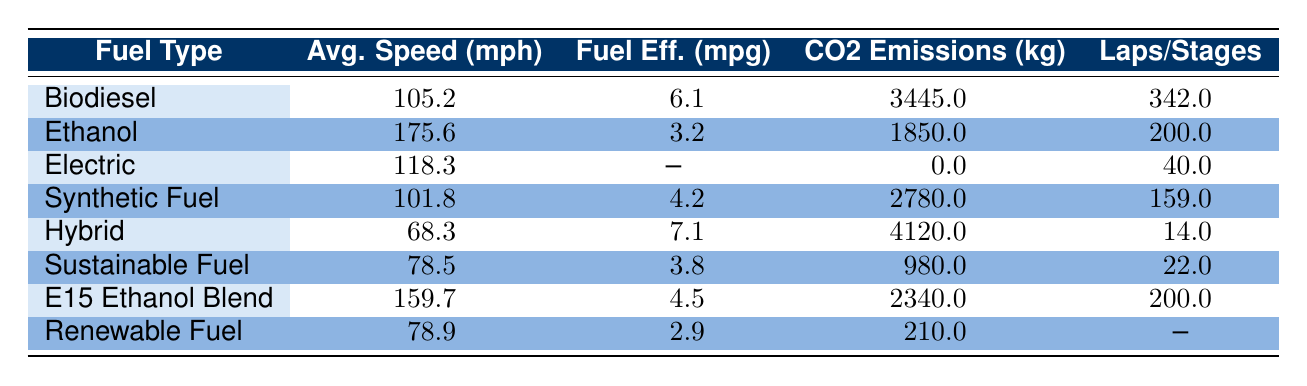What is the average speed of biodiesel-powered race cars? The average speed is determined by looking for all race cars that use biodiesel as their fuel type in the table. The biodiesel entries show speeds of 153.2 mph (from the 24 Hours of Le Mans) and 57.2 mph (from the Baja 1000). To find the average, we sum them (153.2 + 57.2 = 210.4) and divide by the number of entries (2), yielding an average speed of 105.2 mph.
Answer: 105.2 mph Which fuel type had the highest average speed? We need to compare the average speeds listed under each fuel type in the table. The values indicate that ethanol has the highest average speed at 175.6 mph, followed by E15 ethanol blend at 159.7 mph, and biodiesel at 105.2 mph. Therefore, ethanol is the fuel type with the highest average speed.
Answer: Ethanol What is the average CO2 emissions for hybrid race cars? To determine the average CO2 emissions for hybrid vehicles, we locate the hybrid entry, which is from the Dakar Rally with emissions of 4120 kg. Since there is only one hybrid entry in the table, the average is simply 4120 kg.
Answer: 4120 kg Do electric-powered race cars emit any CO2? Examining the CO2 emissions for electric-powered race cars, we find two entries under fuel type "Electric," both of which list 0 kg of CO2 emissions. Since there are no emissions, the statement is true.
Answer: Yes Which fuel type has the lowest fuel efficiency? We can find the fuel efficiency values for all the fuel types in the table. The lowest value is 2.9 mpg, associated with the renewable fuel used in the Pikes Peak International Hill Climb. Therefore, renewable fuel has the lowest fuel efficiency.
Answer: Renewable fuel What is the total number of laps completed by race cars using biodiesel? From the biodiesel entries in the table, the laps completed are 342 (24 Hours of Le Mans) and 200 (Baja 1000). To get the total, we sum the laps: 342 + 200 = 542.
Answer: 542 laps Which fuel type had the lowest CO2 emissions? By checking each fuel type's CO2 emissions, we find the electric cars emitted 0 kg, which is lower than all other fuel types. Therefore, electric-powered race cars had the lowest emissions.
Answer: Electric What is the average fuel efficiency across all race cars using biofuels? To find the average fuel efficiency for biofuels, we look at the relevant fuel types (biodiesel, ethanol, sustainable fuel, and E15 ethanol blend) with efficiencies of 5.8, 3.2, 3.8, and 4.5 mpg respectively. The sum is (5.8 + 3.2 + 3.8 + 4.5 = 17.3). There are 4 entries, so we divide by 4, yielding an average of 4.325 mpg.
Answer: 4.3 mpg 